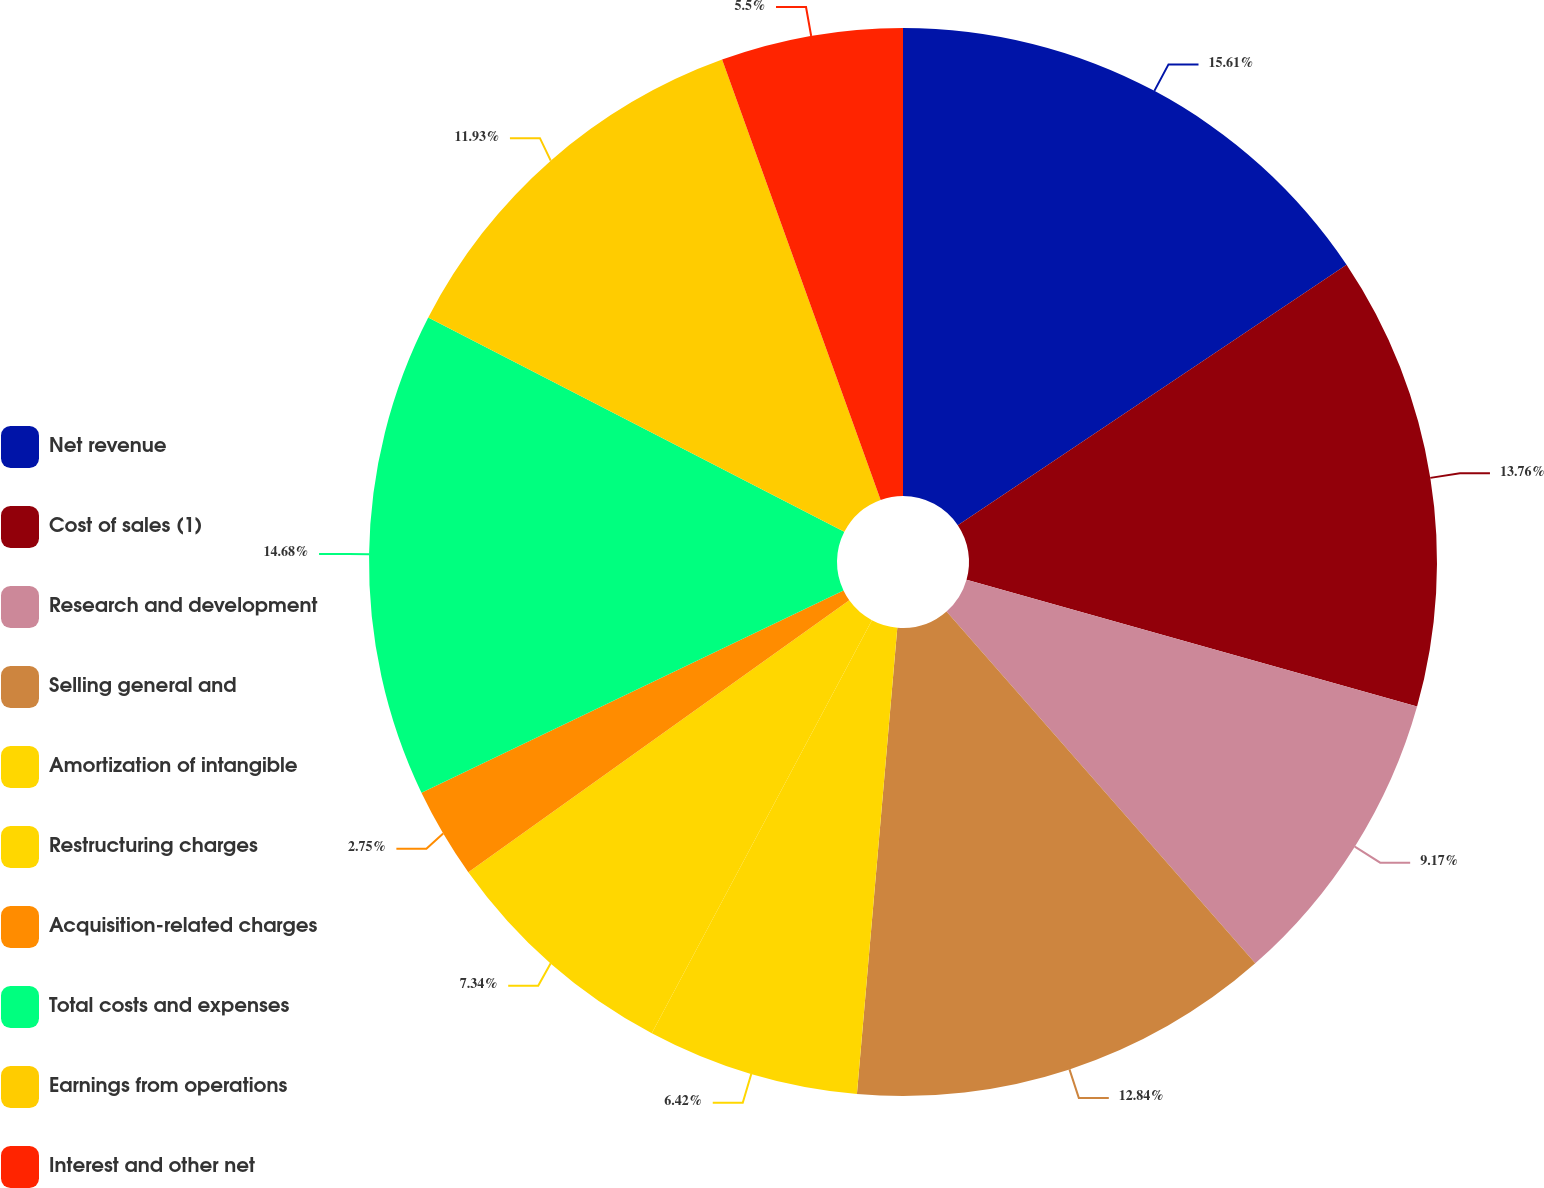Convert chart. <chart><loc_0><loc_0><loc_500><loc_500><pie_chart><fcel>Net revenue<fcel>Cost of sales (1)<fcel>Research and development<fcel>Selling general and<fcel>Amortization of intangible<fcel>Restructuring charges<fcel>Acquisition-related charges<fcel>Total costs and expenses<fcel>Earnings from operations<fcel>Interest and other net<nl><fcel>15.6%<fcel>13.76%<fcel>9.17%<fcel>12.84%<fcel>6.42%<fcel>7.34%<fcel>2.75%<fcel>14.68%<fcel>11.93%<fcel>5.5%<nl></chart> 